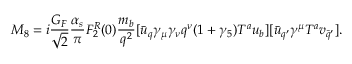<formula> <loc_0><loc_0><loc_500><loc_500>M _ { 8 } = i \frac { G _ { F } } { \sqrt { 2 } } \frac { \alpha _ { s } } { \pi } F _ { 2 } ^ { R } ( 0 ) \frac { m _ { b } } { q ^ { 2 } } [ \bar { u } _ { q } \gamma _ { \mu } \gamma _ { \nu } q ^ { \nu } ( 1 + \gamma _ { 5 } ) T ^ { a } u _ { b } ] [ \bar { u } _ { q ^ { \prime } } \gamma ^ { \mu } T ^ { a } v _ { \bar { q } ^ { \prime } } ] .</formula> 